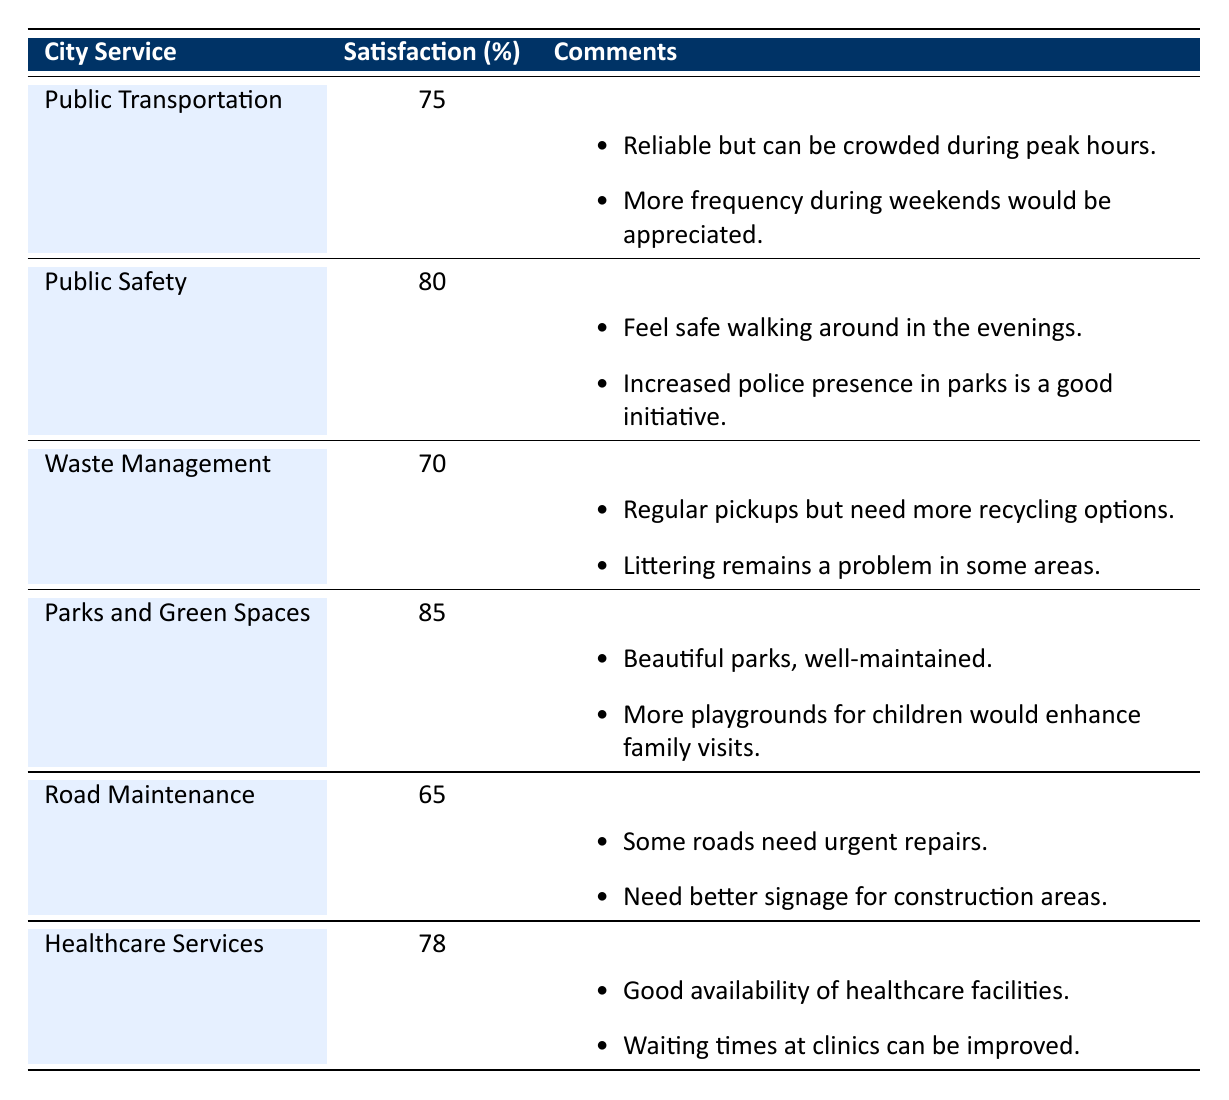What is the satisfaction percentage for Public Safety? The satisfaction percentage for Public Safety is explicitly stated in the table under the "Satisfaction (%)" column corresponding to the "Public Safety" service. It is listed as 80%.
Answer: 80% Which city service has the lowest satisfaction percentage? The city service with the lowest satisfaction percentage can be found by comparing the values in the "Satisfaction (%)" column. The lowest value is 65%, which corresponds to "Road Maintenance."
Answer: Road Maintenance Is the satisfaction percentage for Waste Management greater than or equal to 70%? Waste Management has a satisfaction percentage of 70%, which meets the criteria of being equal to 70% (the condition "greater than or equal to"). Therefore, the answer is yes.
Answer: Yes What is the difference in satisfaction percentage between Parks and Green Spaces and Road Maintenance? The satisfaction percentage for Parks and Green Spaces is 85%, and for Road Maintenance, it is 65%. The difference is calculated as 85% - 65% = 20%.
Answer: 20% Do more residents prefer Parks and Green Spaces over Public Transportation based on satisfaction percentages? Parks and Green Spaces have a satisfaction percentage of 85%, while Public Transportation has a satisfaction percentage of 75%. Since 85% is higher than 75%, more residents prefer Parks and Green Spaces.
Answer: Yes What is the average satisfaction percentage of all city services listed? To find the average satisfaction percentage, we sum the satisfaction percentages: 75 + 80 + 70 + 85 + 65 + 78 = 453. There are 6 services, so we divide 453 by 6, which equals 75.5.
Answer: 75.5 Are there any comments suggesting improvements for Public Transportation? Checking the comments for Public Transportation reveals two specific suggestions: to have more frequency during weekends and to address crowding during peak hours. Since these comments indicate areas for improvement, the answer is yes.
Answer: Yes What is the satisfaction percentage for Healthcare Services, and how does it compare to Waste Management? The satisfaction percentage for Healthcare Services is 78%, while for Waste Management, it is 70%. Since 78% is higher than 70%, Healthcare Services has a higher satisfaction percentage than Waste Management.
Answer: 78% (higher than Waste Management) 